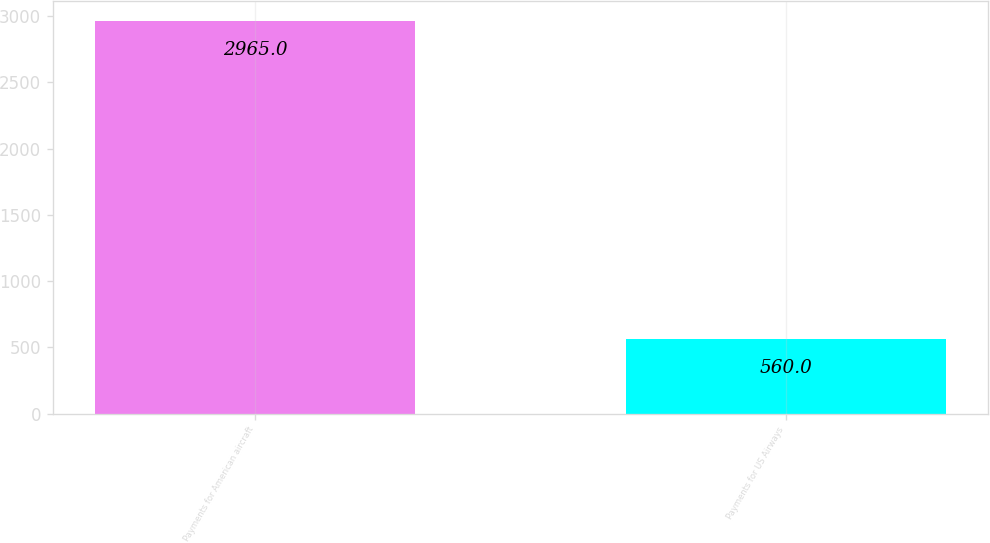<chart> <loc_0><loc_0><loc_500><loc_500><bar_chart><fcel>Payments for American aircraft<fcel>Payments for US Airways<nl><fcel>2965<fcel>560<nl></chart> 